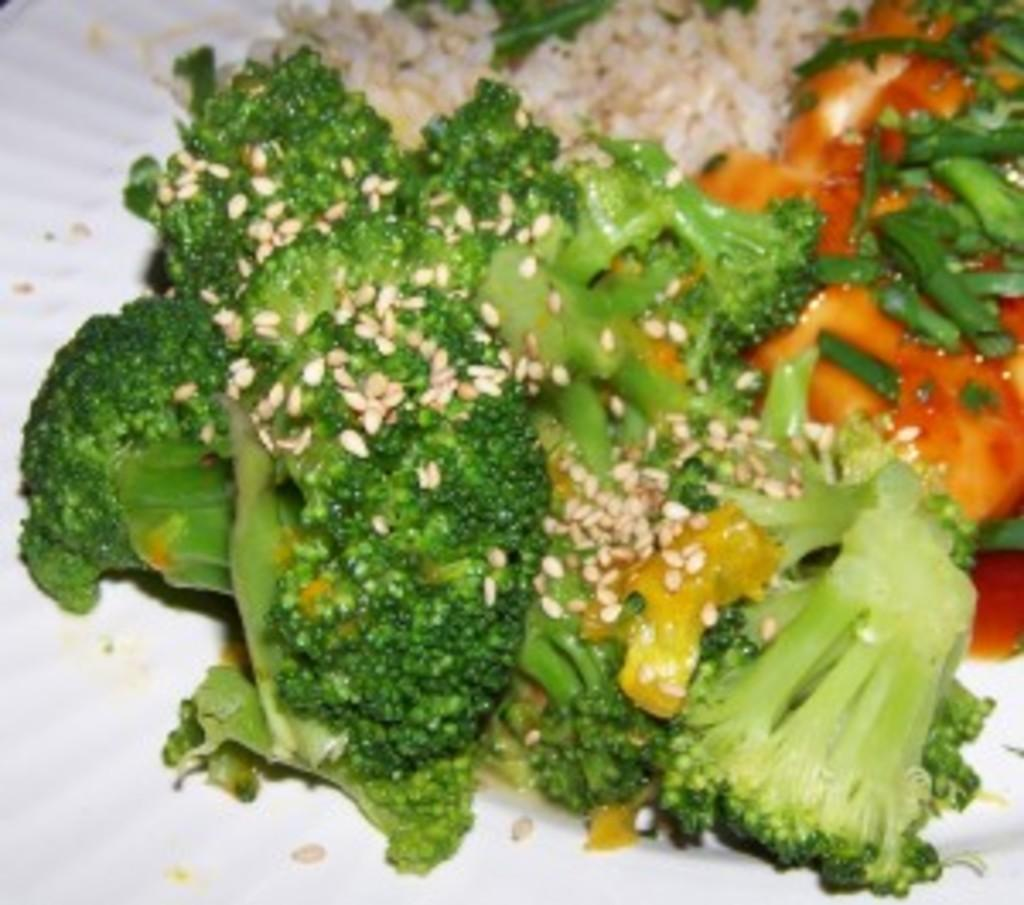What is on the plate in the image? There is a food item on the plate. What type of vegetable can be seen in the food item? The food item contains broccoli pieces. What type of seed is present in the food item? The food item contains sesame seeds. Can you describe any other ingredients in the food item? There are other unspecified items in the food, but their exact nature is not mentioned in the facts. What type of stocking is hanging on the edge of the tray in the image? There is no tray or stocking present in the image; it only features a white plate with a food item on it. 